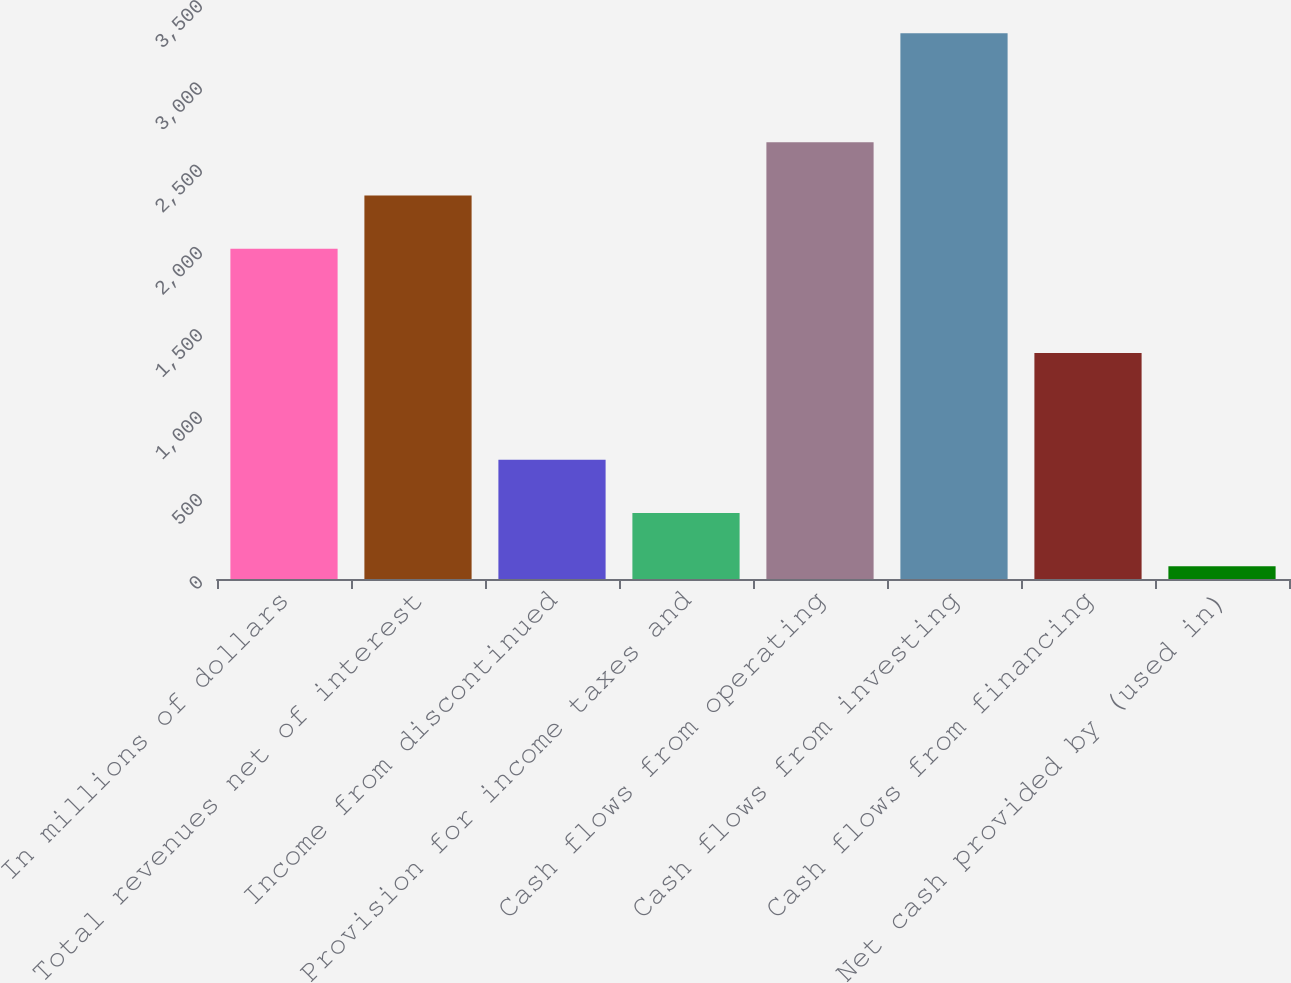Convert chart to OTSL. <chart><loc_0><loc_0><loc_500><loc_500><bar_chart><fcel>In millions of dollars<fcel>Total revenues net of interest<fcel>Income from discontinued<fcel>Provision for income taxes and<fcel>Cash flows from operating<fcel>Cash flows from investing<fcel>Cash flows from financing<fcel>Net cash provided by (used in)<nl><fcel>2006<fcel>2329.9<fcel>724.8<fcel>400.9<fcel>2653.8<fcel>3316<fcel>1372.6<fcel>77<nl></chart> 